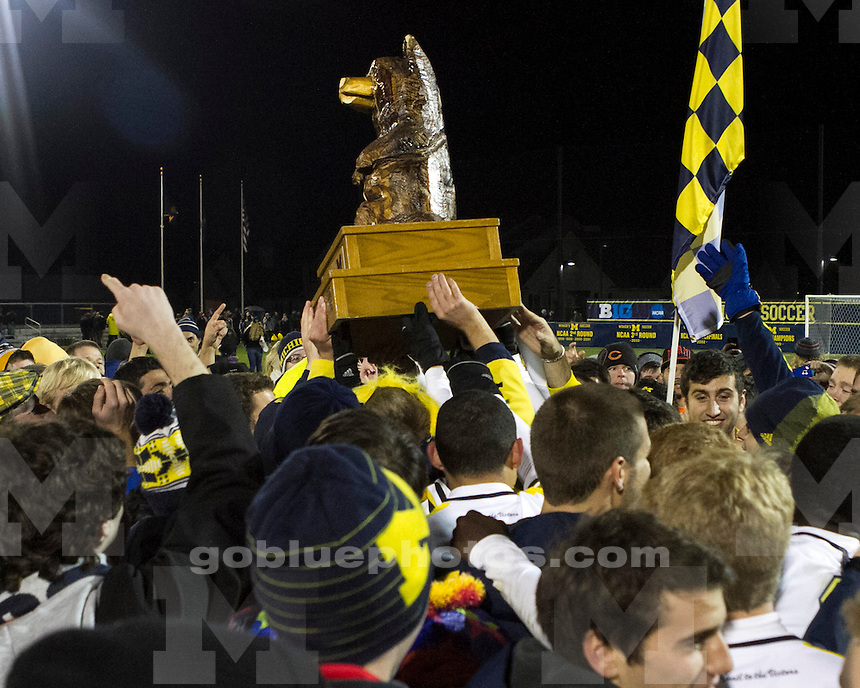What might be the historical significance of the trophy, considering the traditions of sports at the university? The golden wolverine trophy likely holds substantial historical significance, stemming from long-standing traditions at the university. It could be an award handed out for a specific sports achievement, such as winning a particular regional or league championship. Given its iconic design and the robust celebration, it also serves as a link to past victories, weaving a narrative thread that ties current accomplishments to the legacy of the school's sporting prowess. Such trophies do more than commemorate a win; they symbolize the school's ongoing commitment to excellence in sports and unity among its students and alumni. 